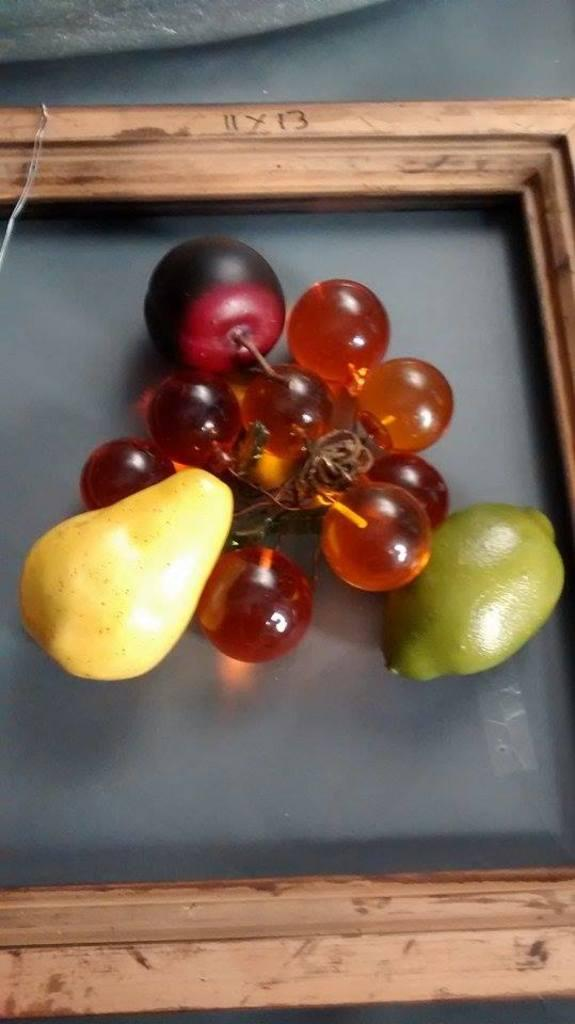What object can be seen in the image that is used for holding items? There is a tray in the image that is used for holding items. What type of food is on the tray in the image? There are fruits on the tray in the image. Is there a woman using a hose to water the fruits on the tray in the image? There is no woman or hose present in the image; it only shows a tray with fruits on it. 